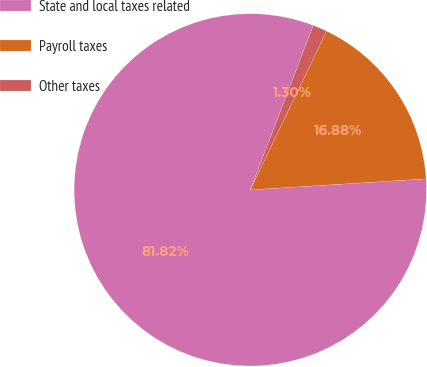Convert chart to OTSL. <chart><loc_0><loc_0><loc_500><loc_500><pie_chart><fcel>State and local taxes related<fcel>Payroll taxes<fcel>Other taxes<nl><fcel>81.82%<fcel>16.88%<fcel>1.3%<nl></chart> 